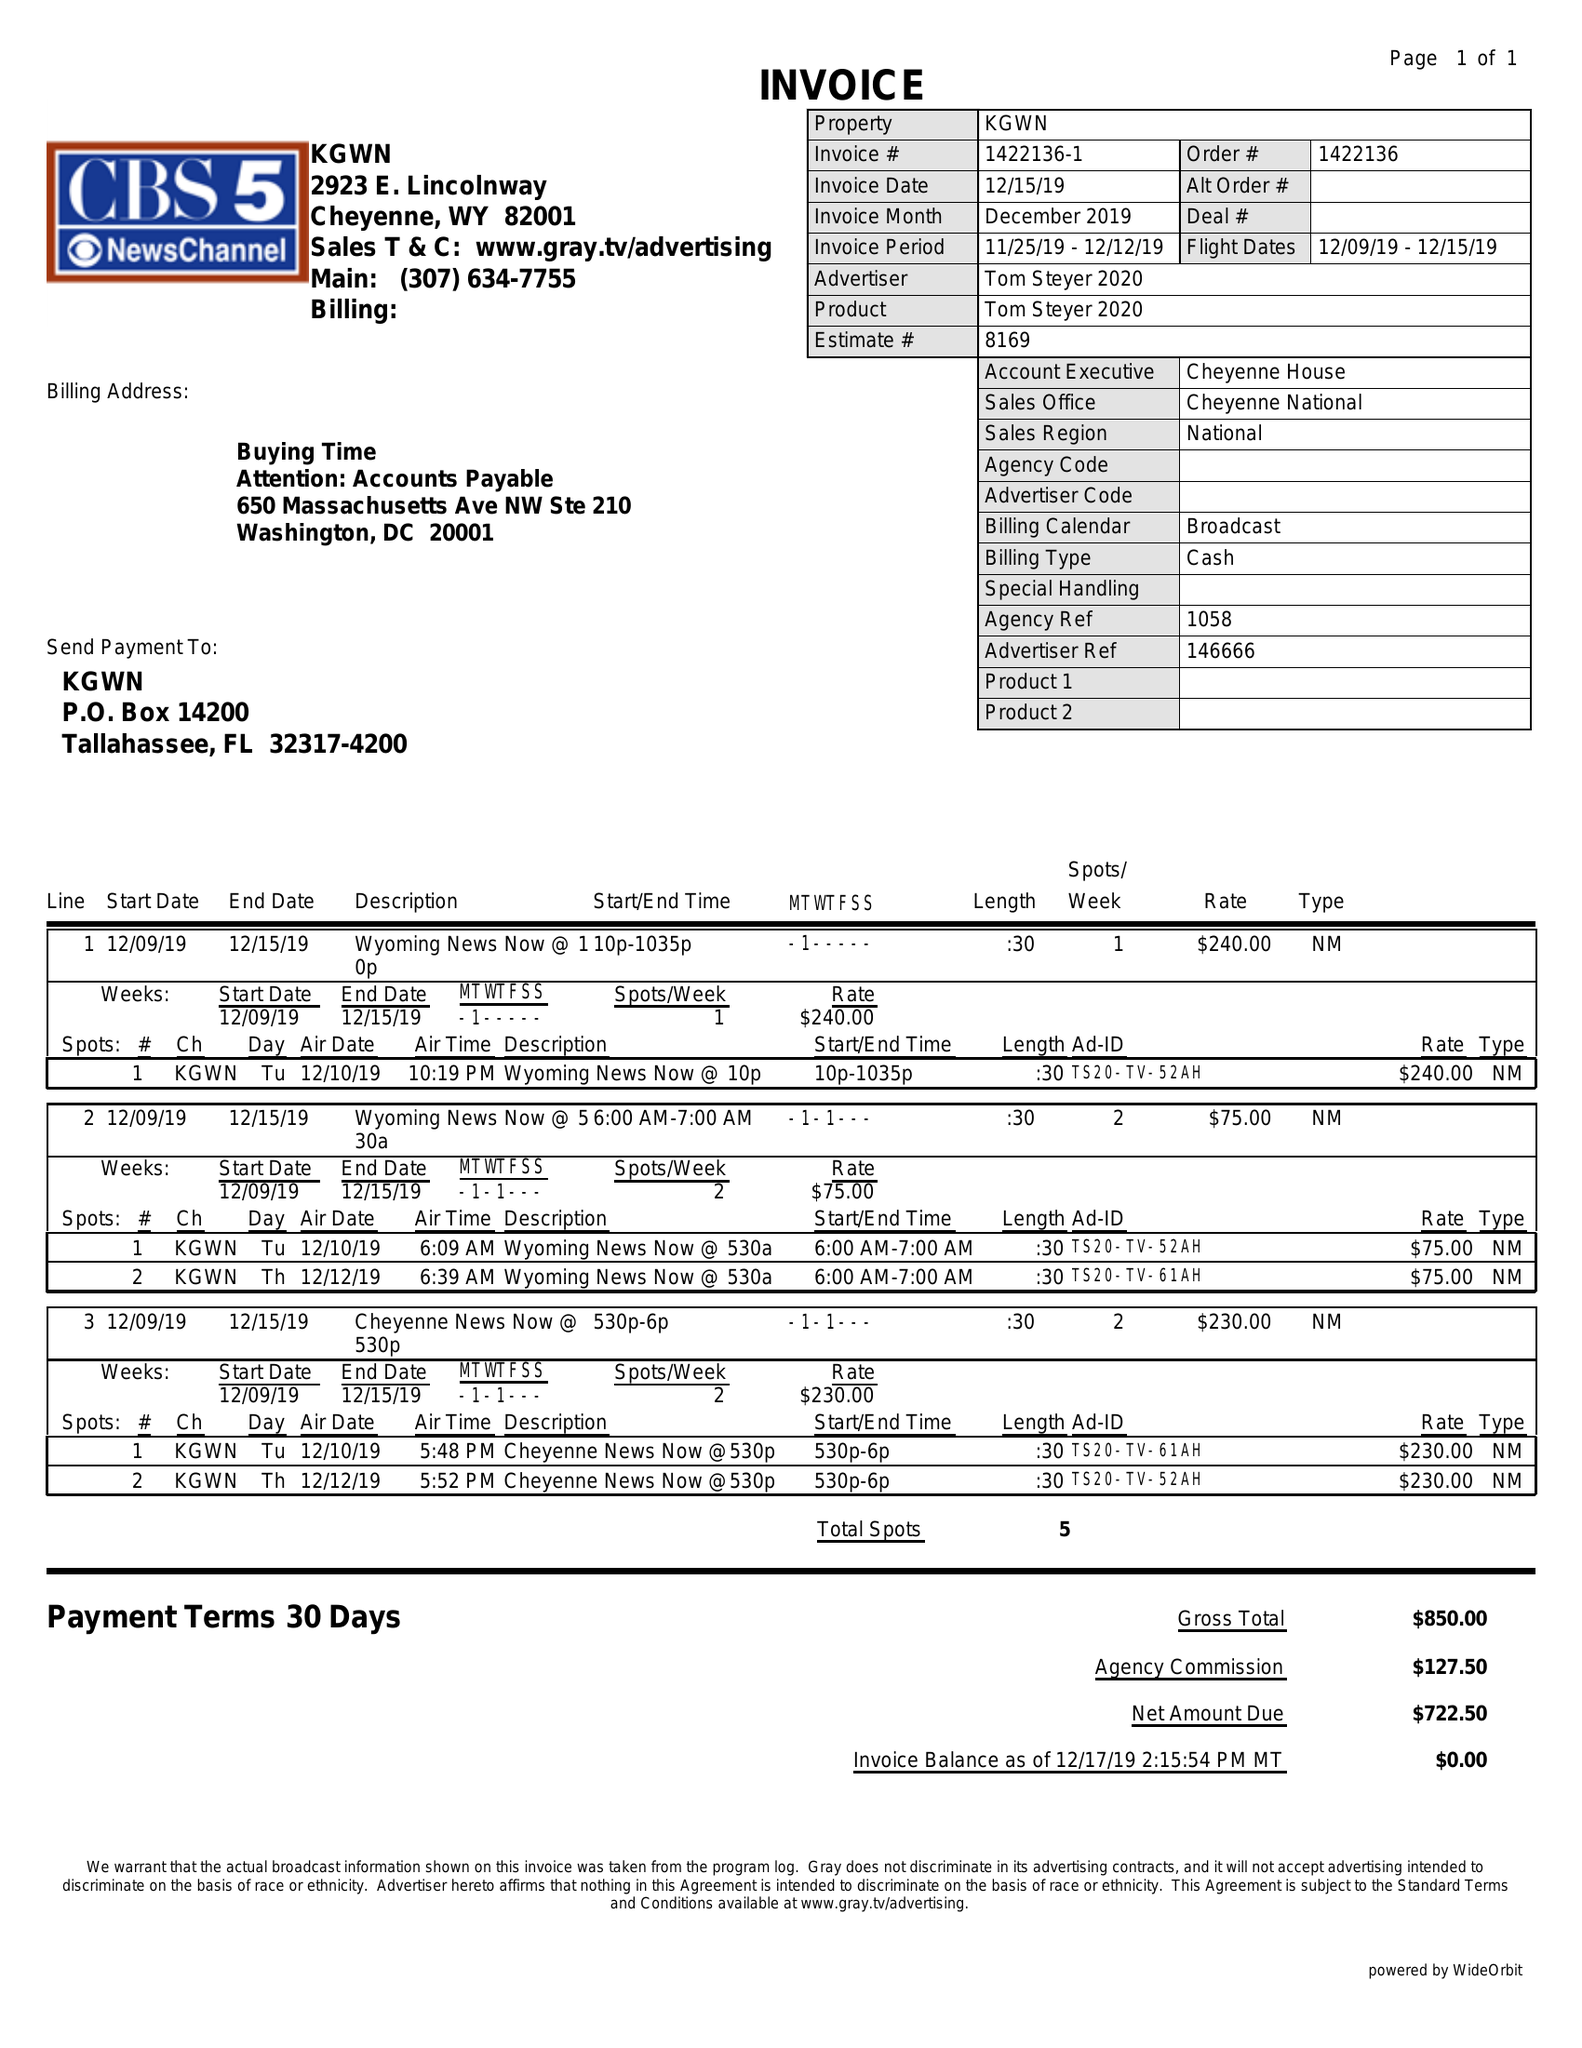What is the value for the advertiser?
Answer the question using a single word or phrase. TOM STEYER 2020 